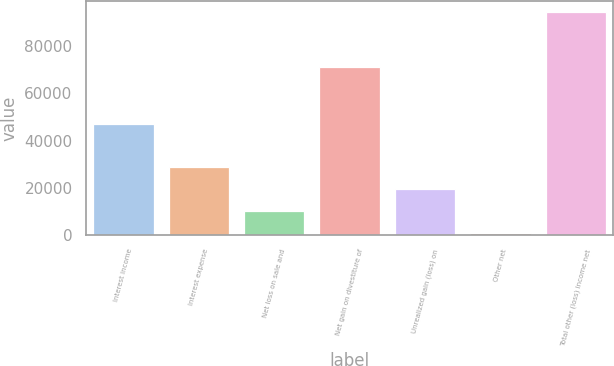Convert chart to OTSL. <chart><loc_0><loc_0><loc_500><loc_500><bar_chart><fcel>Interest income<fcel>Interest expense<fcel>Net loss on sale and<fcel>Net gain on divestiture of<fcel>Unrealized gain (loss) on<fcel>Other net<fcel>Total other (loss) income net<nl><fcel>47074<fcel>28912.2<fcel>10199.4<fcel>71216<fcel>19555.8<fcel>843<fcel>94407<nl></chart> 